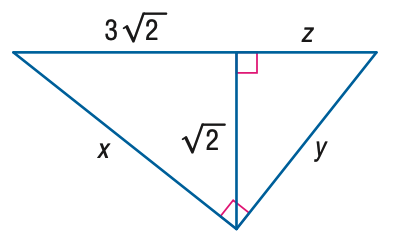Answer the mathemtical geometry problem and directly provide the correct option letter.
Question: Find y.
Choices: A: \frac { 2 } { 3 } \sqrt { 2 } B: \frac { 2 } { 3 } \sqrt { 5 } C: 2 \sqrt { 2 } D: 2 \sqrt { 5 } B 